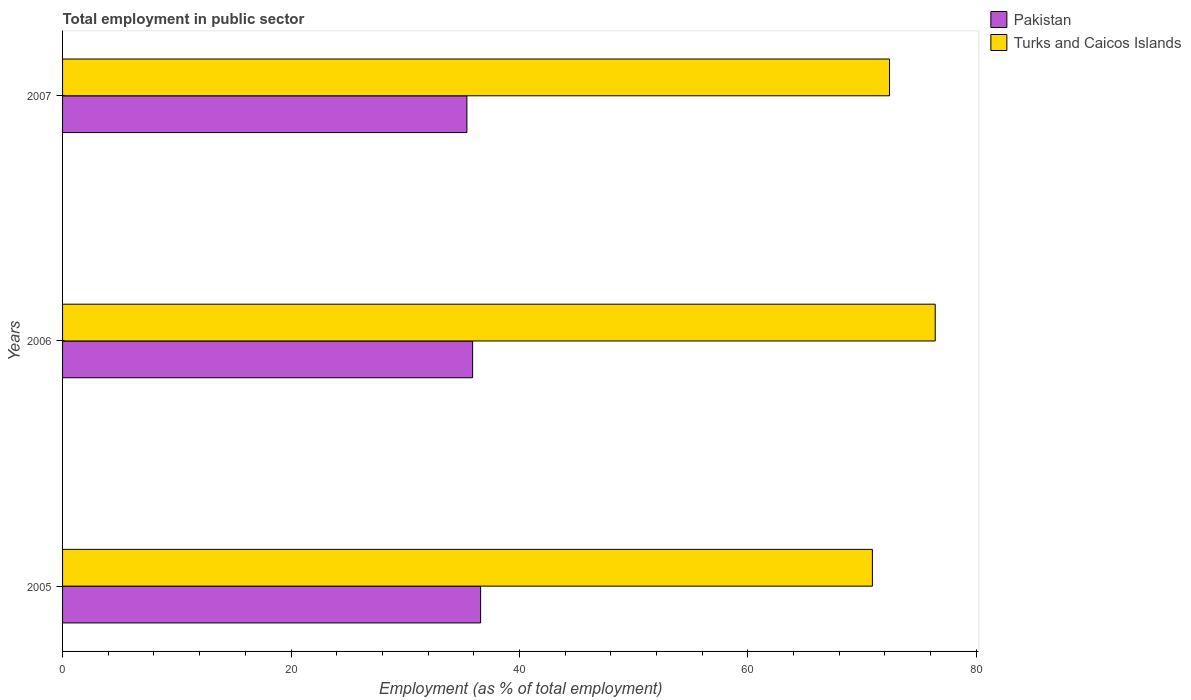How many different coloured bars are there?
Make the answer very short. 2. How many groups of bars are there?
Ensure brevity in your answer.  3. Are the number of bars per tick equal to the number of legend labels?
Offer a terse response. Yes. Are the number of bars on each tick of the Y-axis equal?
Give a very brief answer. Yes. How many bars are there on the 2nd tick from the bottom?
Your answer should be compact. 2. In how many cases, is the number of bars for a given year not equal to the number of legend labels?
Ensure brevity in your answer.  0. What is the employment in public sector in Turks and Caicos Islands in 2007?
Provide a succinct answer. 72.4. Across all years, what is the maximum employment in public sector in Turks and Caicos Islands?
Offer a terse response. 76.4. Across all years, what is the minimum employment in public sector in Pakistan?
Your response must be concise. 35.4. What is the total employment in public sector in Pakistan in the graph?
Give a very brief answer. 107.9. What is the difference between the employment in public sector in Turks and Caicos Islands in 2006 and that in 2007?
Make the answer very short. 4. What is the difference between the employment in public sector in Turks and Caicos Islands in 2005 and the employment in public sector in Pakistan in 2007?
Ensure brevity in your answer.  35.5. What is the average employment in public sector in Pakistan per year?
Your answer should be compact. 35.97. In the year 2007, what is the difference between the employment in public sector in Turks and Caicos Islands and employment in public sector in Pakistan?
Provide a short and direct response. 37. What is the ratio of the employment in public sector in Pakistan in 2005 to that in 2006?
Your response must be concise. 1.02. What is the difference between the highest and the lowest employment in public sector in Pakistan?
Keep it short and to the point. 1.2. In how many years, is the employment in public sector in Pakistan greater than the average employment in public sector in Pakistan taken over all years?
Ensure brevity in your answer.  1. Is the sum of the employment in public sector in Turks and Caicos Islands in 2005 and 2007 greater than the maximum employment in public sector in Pakistan across all years?
Your answer should be very brief. Yes. What does the 1st bar from the top in 2005 represents?
Your response must be concise. Turks and Caicos Islands. What does the 2nd bar from the bottom in 2007 represents?
Ensure brevity in your answer.  Turks and Caicos Islands. How many bars are there?
Make the answer very short. 6. How many years are there in the graph?
Your response must be concise. 3. Are the values on the major ticks of X-axis written in scientific E-notation?
Give a very brief answer. No. Does the graph contain any zero values?
Your answer should be very brief. No. How many legend labels are there?
Keep it short and to the point. 2. How are the legend labels stacked?
Give a very brief answer. Vertical. What is the title of the graph?
Ensure brevity in your answer.  Total employment in public sector. Does "Honduras" appear as one of the legend labels in the graph?
Give a very brief answer. No. What is the label or title of the X-axis?
Ensure brevity in your answer.  Employment (as % of total employment). What is the Employment (as % of total employment) of Pakistan in 2005?
Your response must be concise. 36.6. What is the Employment (as % of total employment) of Turks and Caicos Islands in 2005?
Your answer should be compact. 70.9. What is the Employment (as % of total employment) in Pakistan in 2006?
Provide a succinct answer. 35.9. What is the Employment (as % of total employment) of Turks and Caicos Islands in 2006?
Give a very brief answer. 76.4. What is the Employment (as % of total employment) in Pakistan in 2007?
Your answer should be very brief. 35.4. What is the Employment (as % of total employment) in Turks and Caicos Islands in 2007?
Ensure brevity in your answer.  72.4. Across all years, what is the maximum Employment (as % of total employment) in Pakistan?
Your answer should be very brief. 36.6. Across all years, what is the maximum Employment (as % of total employment) in Turks and Caicos Islands?
Offer a very short reply. 76.4. Across all years, what is the minimum Employment (as % of total employment) of Pakistan?
Keep it short and to the point. 35.4. Across all years, what is the minimum Employment (as % of total employment) in Turks and Caicos Islands?
Your response must be concise. 70.9. What is the total Employment (as % of total employment) in Pakistan in the graph?
Keep it short and to the point. 107.9. What is the total Employment (as % of total employment) in Turks and Caicos Islands in the graph?
Your response must be concise. 219.7. What is the difference between the Employment (as % of total employment) of Pakistan in 2005 and that in 2006?
Your response must be concise. 0.7. What is the difference between the Employment (as % of total employment) in Turks and Caicos Islands in 2005 and that in 2006?
Provide a short and direct response. -5.5. What is the difference between the Employment (as % of total employment) in Pakistan in 2005 and that in 2007?
Offer a terse response. 1.2. What is the difference between the Employment (as % of total employment) in Turks and Caicos Islands in 2005 and that in 2007?
Offer a terse response. -1.5. What is the difference between the Employment (as % of total employment) in Pakistan in 2005 and the Employment (as % of total employment) in Turks and Caicos Islands in 2006?
Keep it short and to the point. -39.8. What is the difference between the Employment (as % of total employment) of Pakistan in 2005 and the Employment (as % of total employment) of Turks and Caicos Islands in 2007?
Offer a very short reply. -35.8. What is the difference between the Employment (as % of total employment) of Pakistan in 2006 and the Employment (as % of total employment) of Turks and Caicos Islands in 2007?
Offer a terse response. -36.5. What is the average Employment (as % of total employment) in Pakistan per year?
Your answer should be compact. 35.97. What is the average Employment (as % of total employment) of Turks and Caicos Islands per year?
Ensure brevity in your answer.  73.23. In the year 2005, what is the difference between the Employment (as % of total employment) of Pakistan and Employment (as % of total employment) of Turks and Caicos Islands?
Make the answer very short. -34.3. In the year 2006, what is the difference between the Employment (as % of total employment) of Pakistan and Employment (as % of total employment) of Turks and Caicos Islands?
Offer a terse response. -40.5. In the year 2007, what is the difference between the Employment (as % of total employment) of Pakistan and Employment (as % of total employment) of Turks and Caicos Islands?
Provide a short and direct response. -37. What is the ratio of the Employment (as % of total employment) of Pakistan in 2005 to that in 2006?
Provide a succinct answer. 1.02. What is the ratio of the Employment (as % of total employment) of Turks and Caicos Islands in 2005 to that in 2006?
Ensure brevity in your answer.  0.93. What is the ratio of the Employment (as % of total employment) in Pakistan in 2005 to that in 2007?
Your response must be concise. 1.03. What is the ratio of the Employment (as % of total employment) of Turks and Caicos Islands in 2005 to that in 2007?
Your response must be concise. 0.98. What is the ratio of the Employment (as % of total employment) of Pakistan in 2006 to that in 2007?
Give a very brief answer. 1.01. What is the ratio of the Employment (as % of total employment) in Turks and Caicos Islands in 2006 to that in 2007?
Keep it short and to the point. 1.06. What is the difference between the highest and the second highest Employment (as % of total employment) in Turks and Caicos Islands?
Provide a short and direct response. 4. What is the difference between the highest and the lowest Employment (as % of total employment) of Pakistan?
Ensure brevity in your answer.  1.2. 